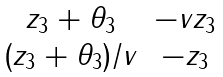<formula> <loc_0><loc_0><loc_500><loc_500>\begin{matrix} z _ { 3 } + \theta _ { 3 } & - v z _ { 3 } \\ ( z _ { 3 } + \theta _ { 3 } ) / v & - z _ { 3 } \end{matrix}</formula> 